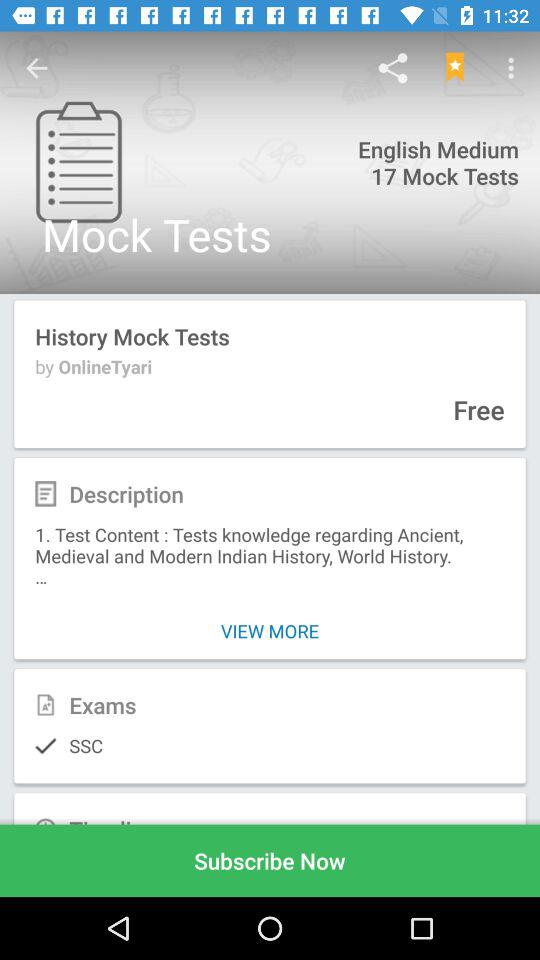Through what application is the person logging in? The person is logging in through Facebook. 